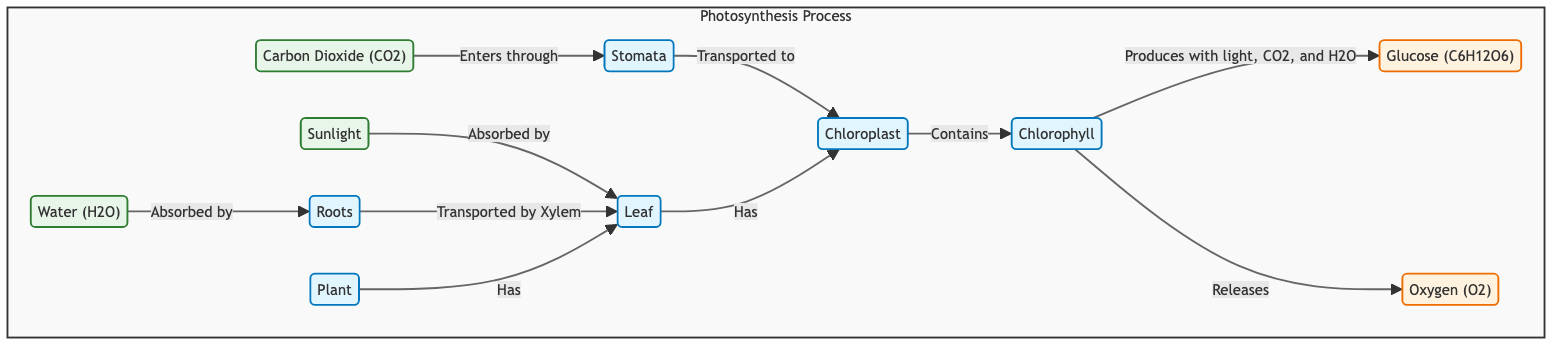What are the input materials for photosynthesis? The diagram shows three input materials for photosynthesis: sunlight, carbon dioxide, and water. They are clearly defined at the beginning of the flow.
Answer: sunlight, carbon dioxide, water Which process absorbs sunlight? The diagram indicates that sunlight is absorbed by the leaf, which is illustrated as the process connected to the sunlight input.
Answer: leaf How is water transported to the leaf? The diagram shows that water is absorbed by roots and then transported by xylem to the leaf, indicating the pathway for water's movement.
Answer: by xylem What does chlorophyll produce during photosynthesis? According to the diagram, chlorophyll, when combined with light, carbon dioxide, and water, produces glucose. This relationship is explicitly stated in the process flow.
Answer: glucose How many outputs are produced by the chlorophyll? The diagram illustrates that chlorophyll produces two outputs: glucose and oxygen. This is noted in the separate paths leading from chlorophyll.
Answer: 2 What enters the plant through the stomata? The diagram specifies that carbon dioxide enters the plant through the stomata, indicating the route for this crucial input.
Answer: carbon dioxide What is the relationship between chloroplasts and chlorophyll? The diagram shows that chloroplasts contain chlorophyll, indicating that chlorophyll is housed within chloroplasts as part of the photosynthesis process.
Answer: contains Where do the roots absorb water from? The diagram states that roots absorb water, specifically from the ground, making it clear how roots acquire this vital resource for photosynthesis.
Answer: ground Which structure releases oxygen? The diagram specifies that oxygen is released by chlorophyll during the process of photosynthesis. This connection is highlighted in the flow of information.
Answer: chlorophyll 